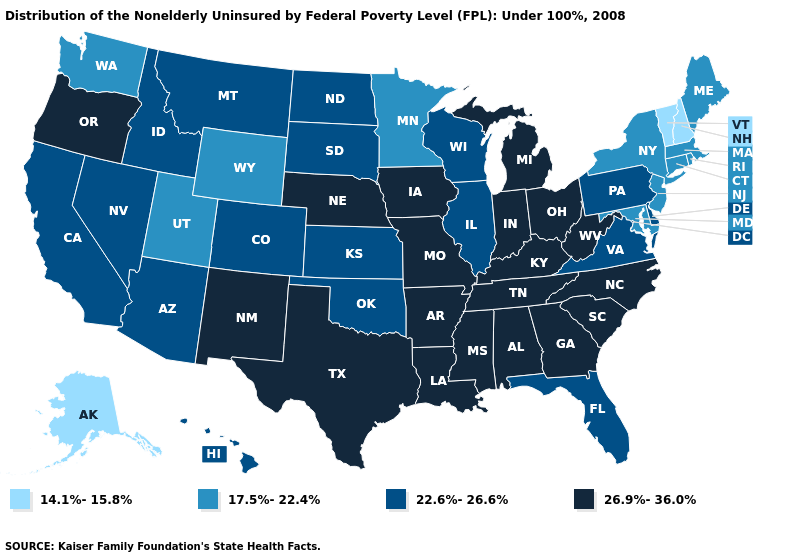How many symbols are there in the legend?
Answer briefly. 4. Is the legend a continuous bar?
Keep it brief. No. Does Pennsylvania have the highest value in the Northeast?
Short answer required. Yes. What is the value of West Virginia?
Write a very short answer. 26.9%-36.0%. What is the highest value in the USA?
Be succinct. 26.9%-36.0%. Name the states that have a value in the range 14.1%-15.8%?
Write a very short answer. Alaska, New Hampshire, Vermont. What is the value of Iowa?
Short answer required. 26.9%-36.0%. Does Kentucky have the same value as Iowa?
Write a very short answer. Yes. Does Virginia have the highest value in the South?
Give a very brief answer. No. What is the value of California?
Keep it brief. 22.6%-26.6%. Does Missouri have a higher value than Oklahoma?
Answer briefly. Yes. Is the legend a continuous bar?
Be succinct. No. What is the highest value in states that border Wyoming?
Answer briefly. 26.9%-36.0%. What is the lowest value in the West?
Keep it brief. 14.1%-15.8%. 